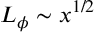Convert formula to latex. <formula><loc_0><loc_0><loc_500><loc_500>L _ { \phi } \sim x ^ { 1 / 2 }</formula> 